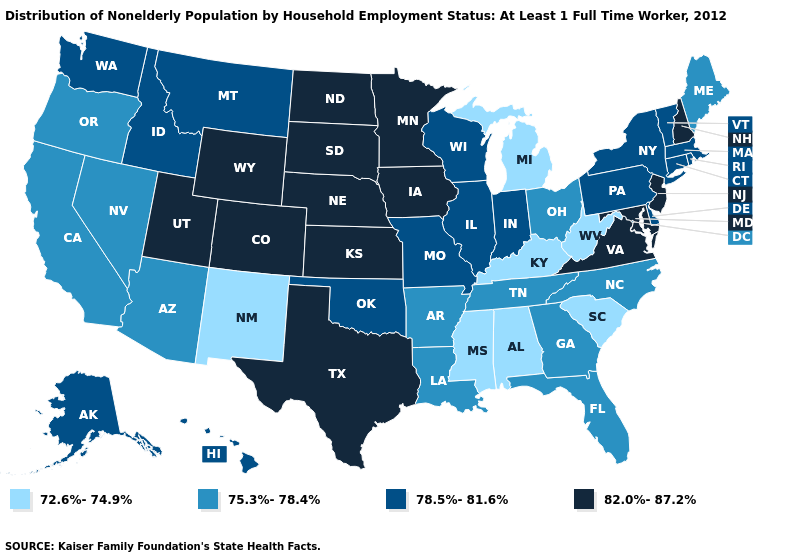Name the states that have a value in the range 78.5%-81.6%?
Keep it brief. Alaska, Connecticut, Delaware, Hawaii, Idaho, Illinois, Indiana, Massachusetts, Missouri, Montana, New York, Oklahoma, Pennsylvania, Rhode Island, Vermont, Washington, Wisconsin. What is the lowest value in the South?
Concise answer only. 72.6%-74.9%. Does Mississippi have the lowest value in the South?
Give a very brief answer. Yes. Name the states that have a value in the range 75.3%-78.4%?
Answer briefly. Arizona, Arkansas, California, Florida, Georgia, Louisiana, Maine, Nevada, North Carolina, Ohio, Oregon, Tennessee. What is the value of California?
Short answer required. 75.3%-78.4%. Which states hav the highest value in the Northeast?
Keep it brief. New Hampshire, New Jersey. What is the highest value in states that border Michigan?
Write a very short answer. 78.5%-81.6%. Is the legend a continuous bar?
Write a very short answer. No. How many symbols are there in the legend?
Be succinct. 4. Among the states that border Mississippi , which have the lowest value?
Quick response, please. Alabama. What is the highest value in the West ?
Keep it brief. 82.0%-87.2%. What is the highest value in states that border Mississippi?
Write a very short answer. 75.3%-78.4%. What is the lowest value in the West?
Write a very short answer. 72.6%-74.9%. Does Mississippi have the lowest value in the USA?
Keep it brief. Yes. What is the value of Florida?
Concise answer only. 75.3%-78.4%. 